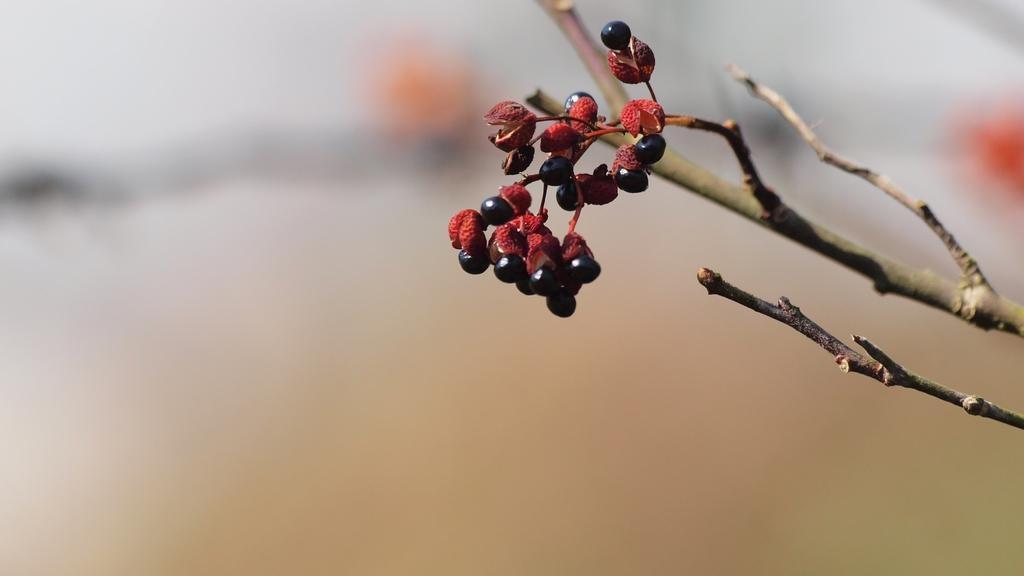How would you summarize this image in a sentence or two? In this picture we can see berries and branches. There is a blur background. 